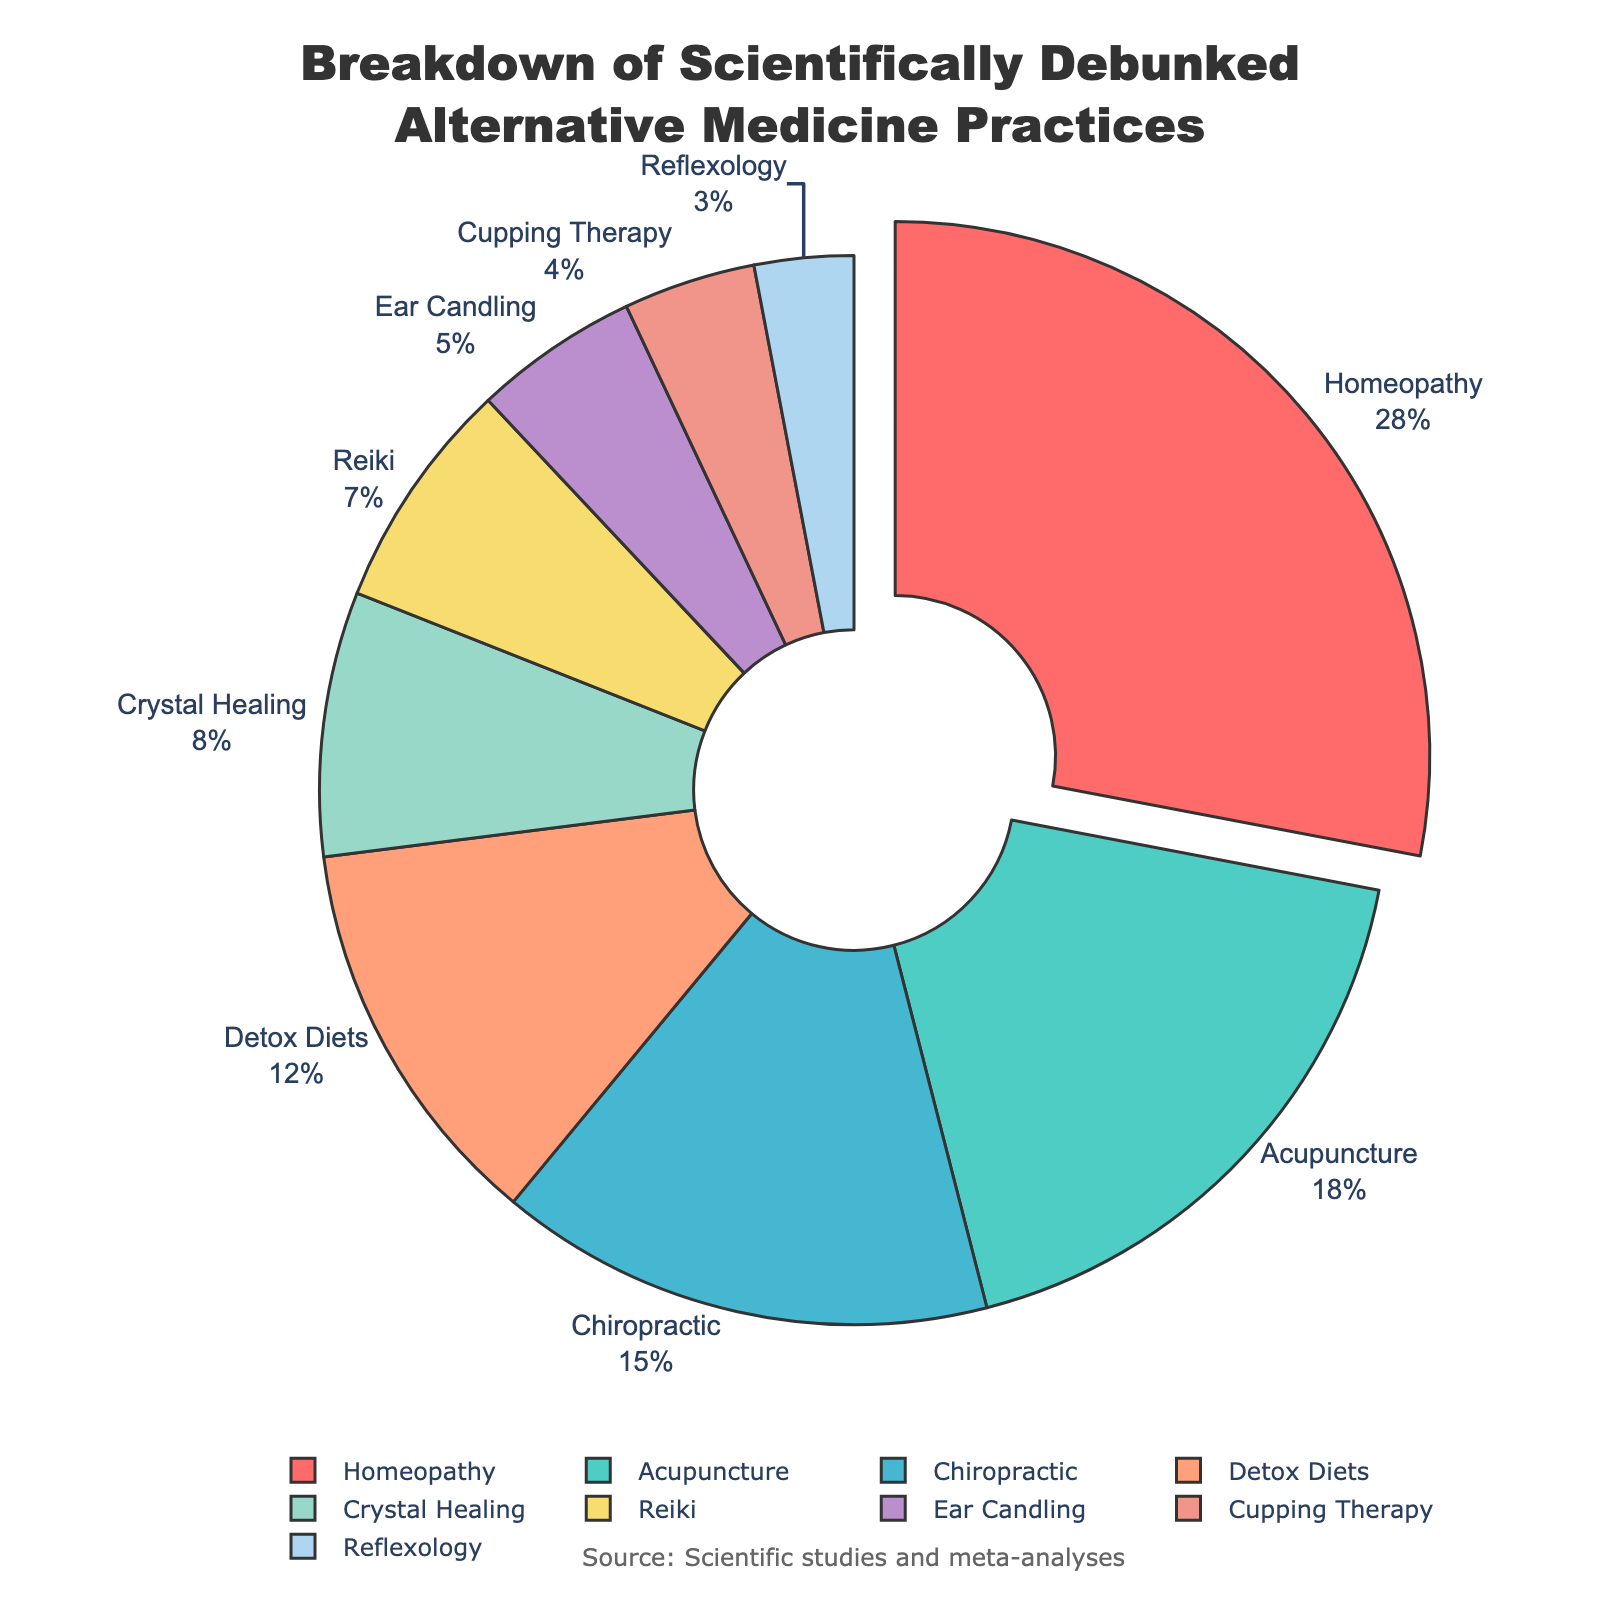What is the largest segment in the pie chart and its percentage? The pie chart's largest segment represents the practice with the highest percentage. By looking at the pie chart, notice the "Homeopathy" segment is visually the largest. The percentage associated with Homeopathy is 28%.
Answer: Homeopathy, 28% How do the percentages of Acupuncture and Chiropractic compare? Comparing the segments for Acupuncture and Chiropractic, Acupuncture comes second with 18%, and Chiropractic comes third with 15%. Acupuncture has a higher percentage.
Answer: Acupuncture has a higher percentage at 18% compared to Chiropractic's 15% What is the total percentage for Detox Diets, Crystal Healing, and Reiki combined? Adding the percentages for Detox Diets (12%), Crystal Healing (8%), and Reiki (7%) results in 12 + 8 + 7 = 27.
Answer: 27% Which segment accounts for the smallest percentage? In the pie chart, the smallest segment corresponds to the lowest percentage value, which is Reflexology at 3%.
Answer: Reflexology, 3% Are there more practices with percentages above or below 10%? Count the number of practices above and below 10%: Above 10% - Homeopathy, Acupuncture, Chiropractic, Detox Diets (4), Below 10% - Crystal Healing, Reiki, Ear Candling, Cupping Therapy, Reflexology (5). There are more practices below 10%.
Answer: Below, 5 practices By how much does the percentage for Homeopathy exceed the combined percentage for Ear Candling, Cupping Therapy, and Reflexology? First, sum the percentages for Ear Candling (5%), Cupping Therapy (4%), and Reflexology (3%), yielding 5 + 4 + 3 = 12. Then, find the difference: 28 (Homeopathy) - 12 = 16.
Answer: 16% What is the ratio of the percentage of Crystal Healing to Reiki? To obtain the ratio, divide the percentage of Crystal Healing (8%) by Reiki (7%): 8/7 = 1.14.
Answer: 1.14 Which practices collectively make up exactly half of the total chart's percentage? Determine which combinations of practices add up to 50%. Homeopathy (28%) + Acupuncture (18%) + Chiropractic (15%) = 61%. Checking other combinations: Homeopathy (28%) + Acupuncture (18%) + Detox Diets (4%) + Crystal Healing (8%) + Reiki (7%) = 47%. These don't work either. Eventually, Homeopathy (28%) + Acupuncture (18%) + Ear Candling (5%) = 51%. Finding exactly 50%, Homeopathy (28%) + Chiropractic (15%) + Reflexology (3%) = 46%. Hence, Homeopathy, Acupuncture and Reiki.
Answer: Homeopathy, Acupuncture, Reiki How does the percentage of practices above 15% compare to the total of those below 15%? Sum of percentages above 15%: Homeopathy (28%) + Acupuncture (18%) + Chiropractic (15%) = 61%. Sum of percentages below 15%: Detox Diets (12%) + Crystal Healing (8%) + Reiki (7%) + Ear Candling (5%) + Cupping Therapy (4%) + Reflexology (3%) = 39%. Therefore, practices above 15% collectively make up more of the total percentage.
Answer: Above 15% is more, 61% vs 39% 